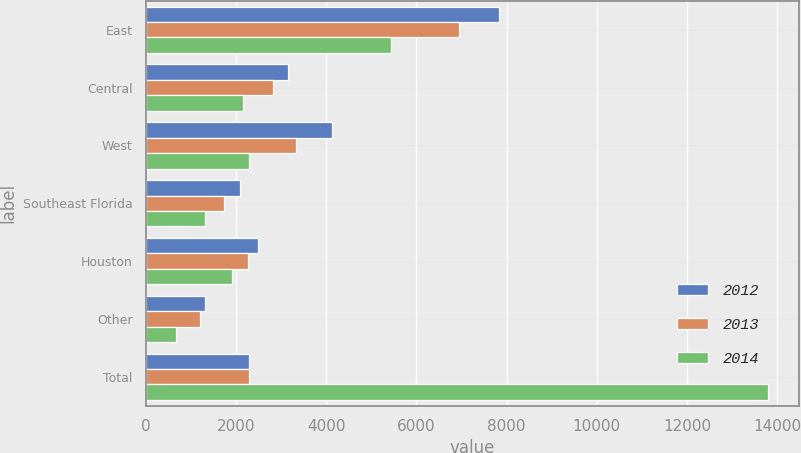Convert chart. <chart><loc_0><loc_0><loc_500><loc_500><stacked_bar_chart><ecel><fcel>East<fcel>Central<fcel>West<fcel>Southeast Florida<fcel>Houston<fcel>Other<fcel>Total<nl><fcel>2012<fcel>7824<fcel>3156<fcel>4141<fcel>2086<fcel>2482<fcel>1314<fcel>2301<nl><fcel>2013<fcel>6941<fcel>2814<fcel>3323<fcel>1741<fcel>2266<fcel>1205<fcel>2301<nl><fcel>2014<fcel>5440<fcel>2154<fcel>2301<fcel>1314<fcel>1917<fcel>676<fcel>13802<nl></chart> 